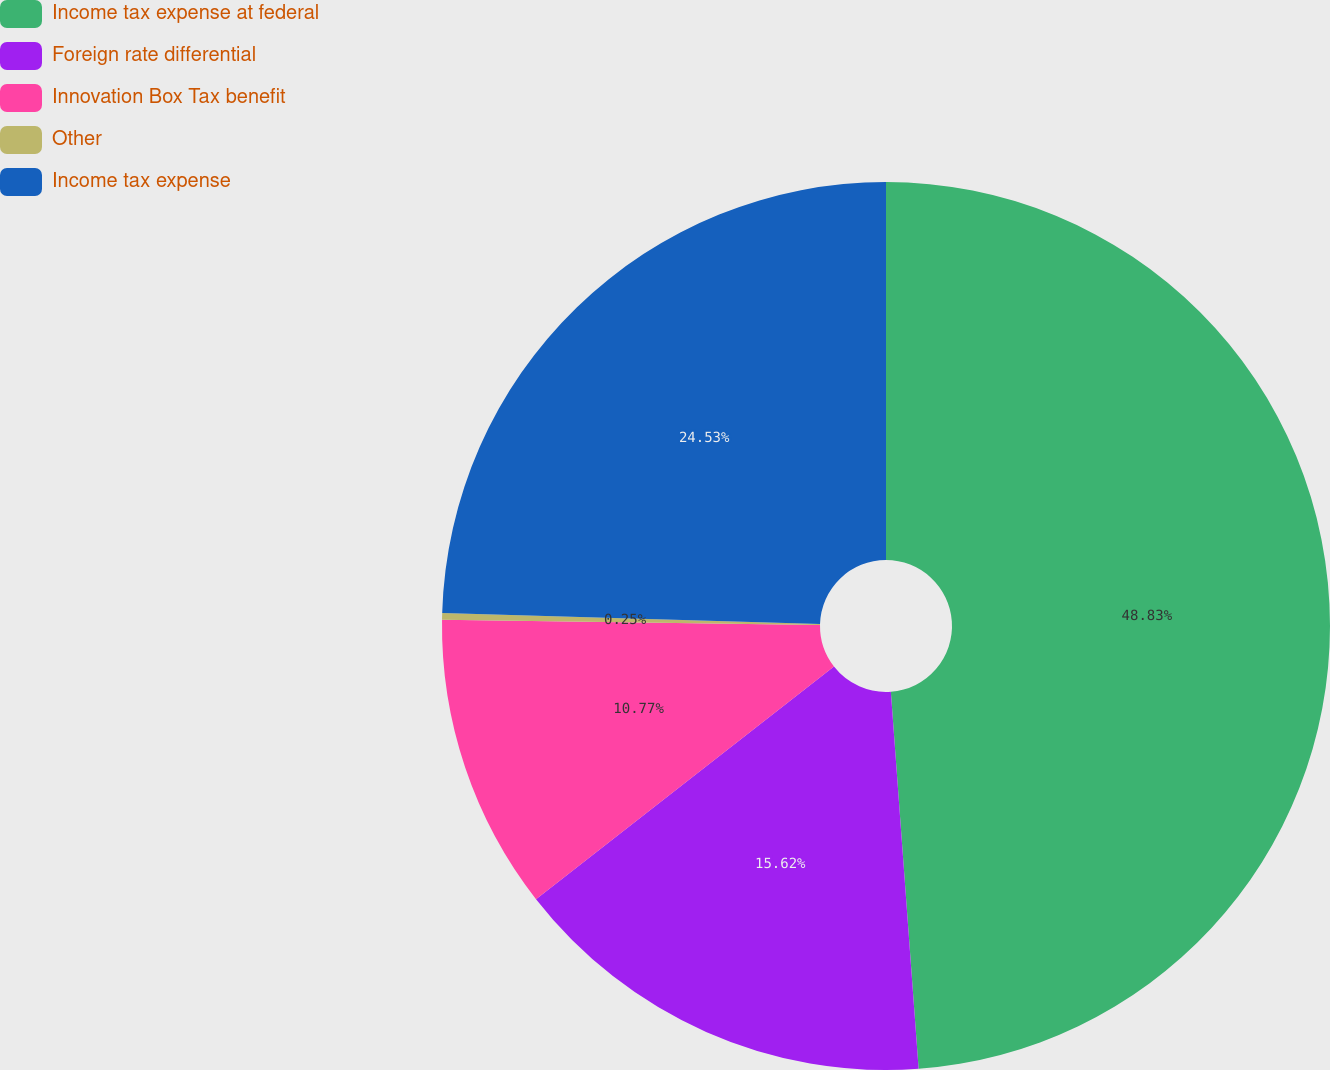<chart> <loc_0><loc_0><loc_500><loc_500><pie_chart><fcel>Income tax expense at federal<fcel>Foreign rate differential<fcel>Innovation Box Tax benefit<fcel>Other<fcel>Income tax expense<nl><fcel>48.83%<fcel>15.62%<fcel>10.77%<fcel>0.25%<fcel>24.53%<nl></chart> 